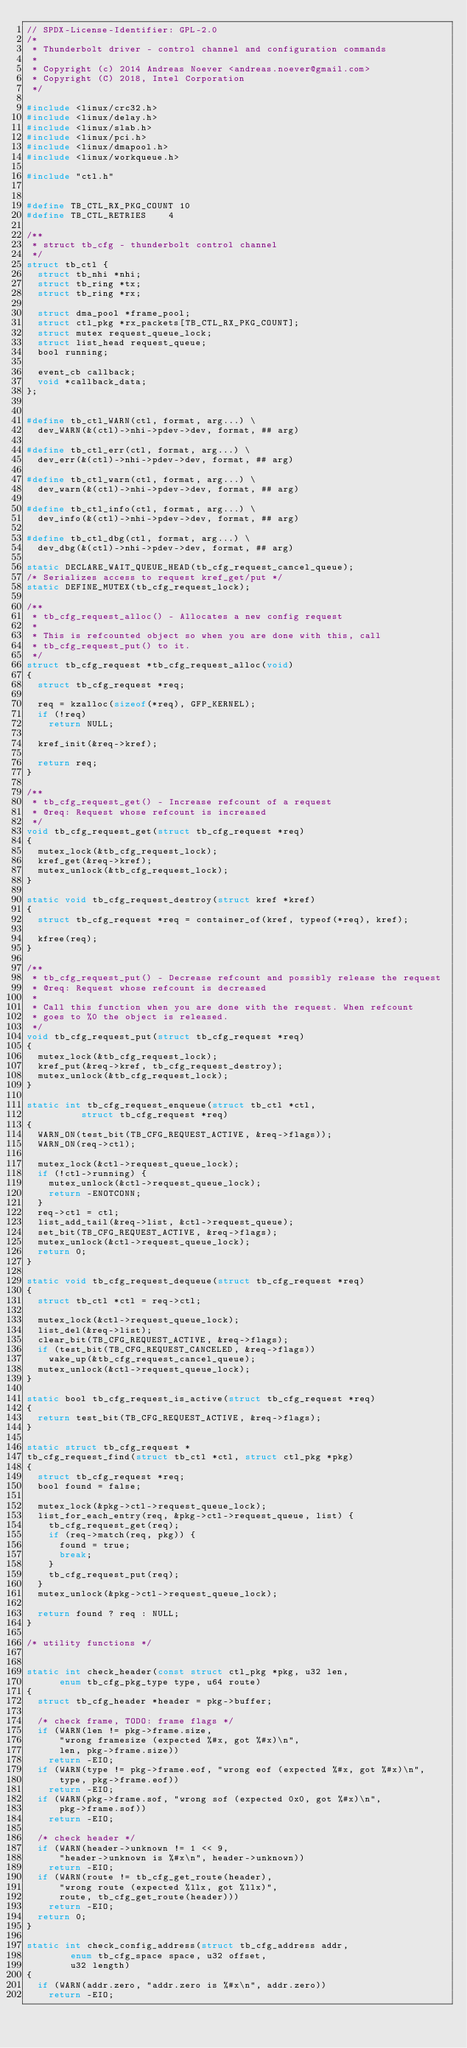<code> <loc_0><loc_0><loc_500><loc_500><_C_>// SPDX-License-Identifier: GPL-2.0
/*
 * Thunderbolt driver - control channel and configuration commands
 *
 * Copyright (c) 2014 Andreas Noever <andreas.noever@gmail.com>
 * Copyright (C) 2018, Intel Corporation
 */

#include <linux/crc32.h>
#include <linux/delay.h>
#include <linux/slab.h>
#include <linux/pci.h>
#include <linux/dmapool.h>
#include <linux/workqueue.h>

#include "ctl.h"


#define TB_CTL_RX_PKG_COUNT	10
#define TB_CTL_RETRIES		4

/**
 * struct tb_cfg - thunderbolt control channel
 */
struct tb_ctl {
	struct tb_nhi *nhi;
	struct tb_ring *tx;
	struct tb_ring *rx;

	struct dma_pool *frame_pool;
	struct ctl_pkg *rx_packets[TB_CTL_RX_PKG_COUNT];
	struct mutex request_queue_lock;
	struct list_head request_queue;
	bool running;

	event_cb callback;
	void *callback_data;
};


#define tb_ctl_WARN(ctl, format, arg...) \
	dev_WARN(&(ctl)->nhi->pdev->dev, format, ## arg)

#define tb_ctl_err(ctl, format, arg...) \
	dev_err(&(ctl)->nhi->pdev->dev, format, ## arg)

#define tb_ctl_warn(ctl, format, arg...) \
	dev_warn(&(ctl)->nhi->pdev->dev, format, ## arg)

#define tb_ctl_info(ctl, format, arg...) \
	dev_info(&(ctl)->nhi->pdev->dev, format, ## arg)

#define tb_ctl_dbg(ctl, format, arg...) \
	dev_dbg(&(ctl)->nhi->pdev->dev, format, ## arg)

static DECLARE_WAIT_QUEUE_HEAD(tb_cfg_request_cancel_queue);
/* Serializes access to request kref_get/put */
static DEFINE_MUTEX(tb_cfg_request_lock);

/**
 * tb_cfg_request_alloc() - Allocates a new config request
 *
 * This is refcounted object so when you are done with this, call
 * tb_cfg_request_put() to it.
 */
struct tb_cfg_request *tb_cfg_request_alloc(void)
{
	struct tb_cfg_request *req;

	req = kzalloc(sizeof(*req), GFP_KERNEL);
	if (!req)
		return NULL;

	kref_init(&req->kref);

	return req;
}

/**
 * tb_cfg_request_get() - Increase refcount of a request
 * @req: Request whose refcount is increased
 */
void tb_cfg_request_get(struct tb_cfg_request *req)
{
	mutex_lock(&tb_cfg_request_lock);
	kref_get(&req->kref);
	mutex_unlock(&tb_cfg_request_lock);
}

static void tb_cfg_request_destroy(struct kref *kref)
{
	struct tb_cfg_request *req = container_of(kref, typeof(*req), kref);

	kfree(req);
}

/**
 * tb_cfg_request_put() - Decrease refcount and possibly release the request
 * @req: Request whose refcount is decreased
 *
 * Call this function when you are done with the request. When refcount
 * goes to %0 the object is released.
 */
void tb_cfg_request_put(struct tb_cfg_request *req)
{
	mutex_lock(&tb_cfg_request_lock);
	kref_put(&req->kref, tb_cfg_request_destroy);
	mutex_unlock(&tb_cfg_request_lock);
}

static int tb_cfg_request_enqueue(struct tb_ctl *ctl,
				  struct tb_cfg_request *req)
{
	WARN_ON(test_bit(TB_CFG_REQUEST_ACTIVE, &req->flags));
	WARN_ON(req->ctl);

	mutex_lock(&ctl->request_queue_lock);
	if (!ctl->running) {
		mutex_unlock(&ctl->request_queue_lock);
		return -ENOTCONN;
	}
	req->ctl = ctl;
	list_add_tail(&req->list, &ctl->request_queue);
	set_bit(TB_CFG_REQUEST_ACTIVE, &req->flags);
	mutex_unlock(&ctl->request_queue_lock);
	return 0;
}

static void tb_cfg_request_dequeue(struct tb_cfg_request *req)
{
	struct tb_ctl *ctl = req->ctl;

	mutex_lock(&ctl->request_queue_lock);
	list_del(&req->list);
	clear_bit(TB_CFG_REQUEST_ACTIVE, &req->flags);
	if (test_bit(TB_CFG_REQUEST_CANCELED, &req->flags))
		wake_up(&tb_cfg_request_cancel_queue);
	mutex_unlock(&ctl->request_queue_lock);
}

static bool tb_cfg_request_is_active(struct tb_cfg_request *req)
{
	return test_bit(TB_CFG_REQUEST_ACTIVE, &req->flags);
}

static struct tb_cfg_request *
tb_cfg_request_find(struct tb_ctl *ctl, struct ctl_pkg *pkg)
{
	struct tb_cfg_request *req;
	bool found = false;

	mutex_lock(&pkg->ctl->request_queue_lock);
	list_for_each_entry(req, &pkg->ctl->request_queue, list) {
		tb_cfg_request_get(req);
		if (req->match(req, pkg)) {
			found = true;
			break;
		}
		tb_cfg_request_put(req);
	}
	mutex_unlock(&pkg->ctl->request_queue_lock);

	return found ? req : NULL;
}

/* utility functions */


static int check_header(const struct ctl_pkg *pkg, u32 len,
			enum tb_cfg_pkg_type type, u64 route)
{
	struct tb_cfg_header *header = pkg->buffer;

	/* check frame, TODO: frame flags */
	if (WARN(len != pkg->frame.size,
			"wrong framesize (expected %#x, got %#x)\n",
			len, pkg->frame.size))
		return -EIO;
	if (WARN(type != pkg->frame.eof, "wrong eof (expected %#x, got %#x)\n",
			type, pkg->frame.eof))
		return -EIO;
	if (WARN(pkg->frame.sof, "wrong sof (expected 0x0, got %#x)\n",
			pkg->frame.sof))
		return -EIO;

	/* check header */
	if (WARN(header->unknown != 1 << 9,
			"header->unknown is %#x\n", header->unknown))
		return -EIO;
	if (WARN(route != tb_cfg_get_route(header),
			"wrong route (expected %llx, got %llx)",
			route, tb_cfg_get_route(header)))
		return -EIO;
	return 0;
}

static int check_config_address(struct tb_cfg_address addr,
				enum tb_cfg_space space, u32 offset,
				u32 length)
{
	if (WARN(addr.zero, "addr.zero is %#x\n", addr.zero))
		return -EIO;</code> 